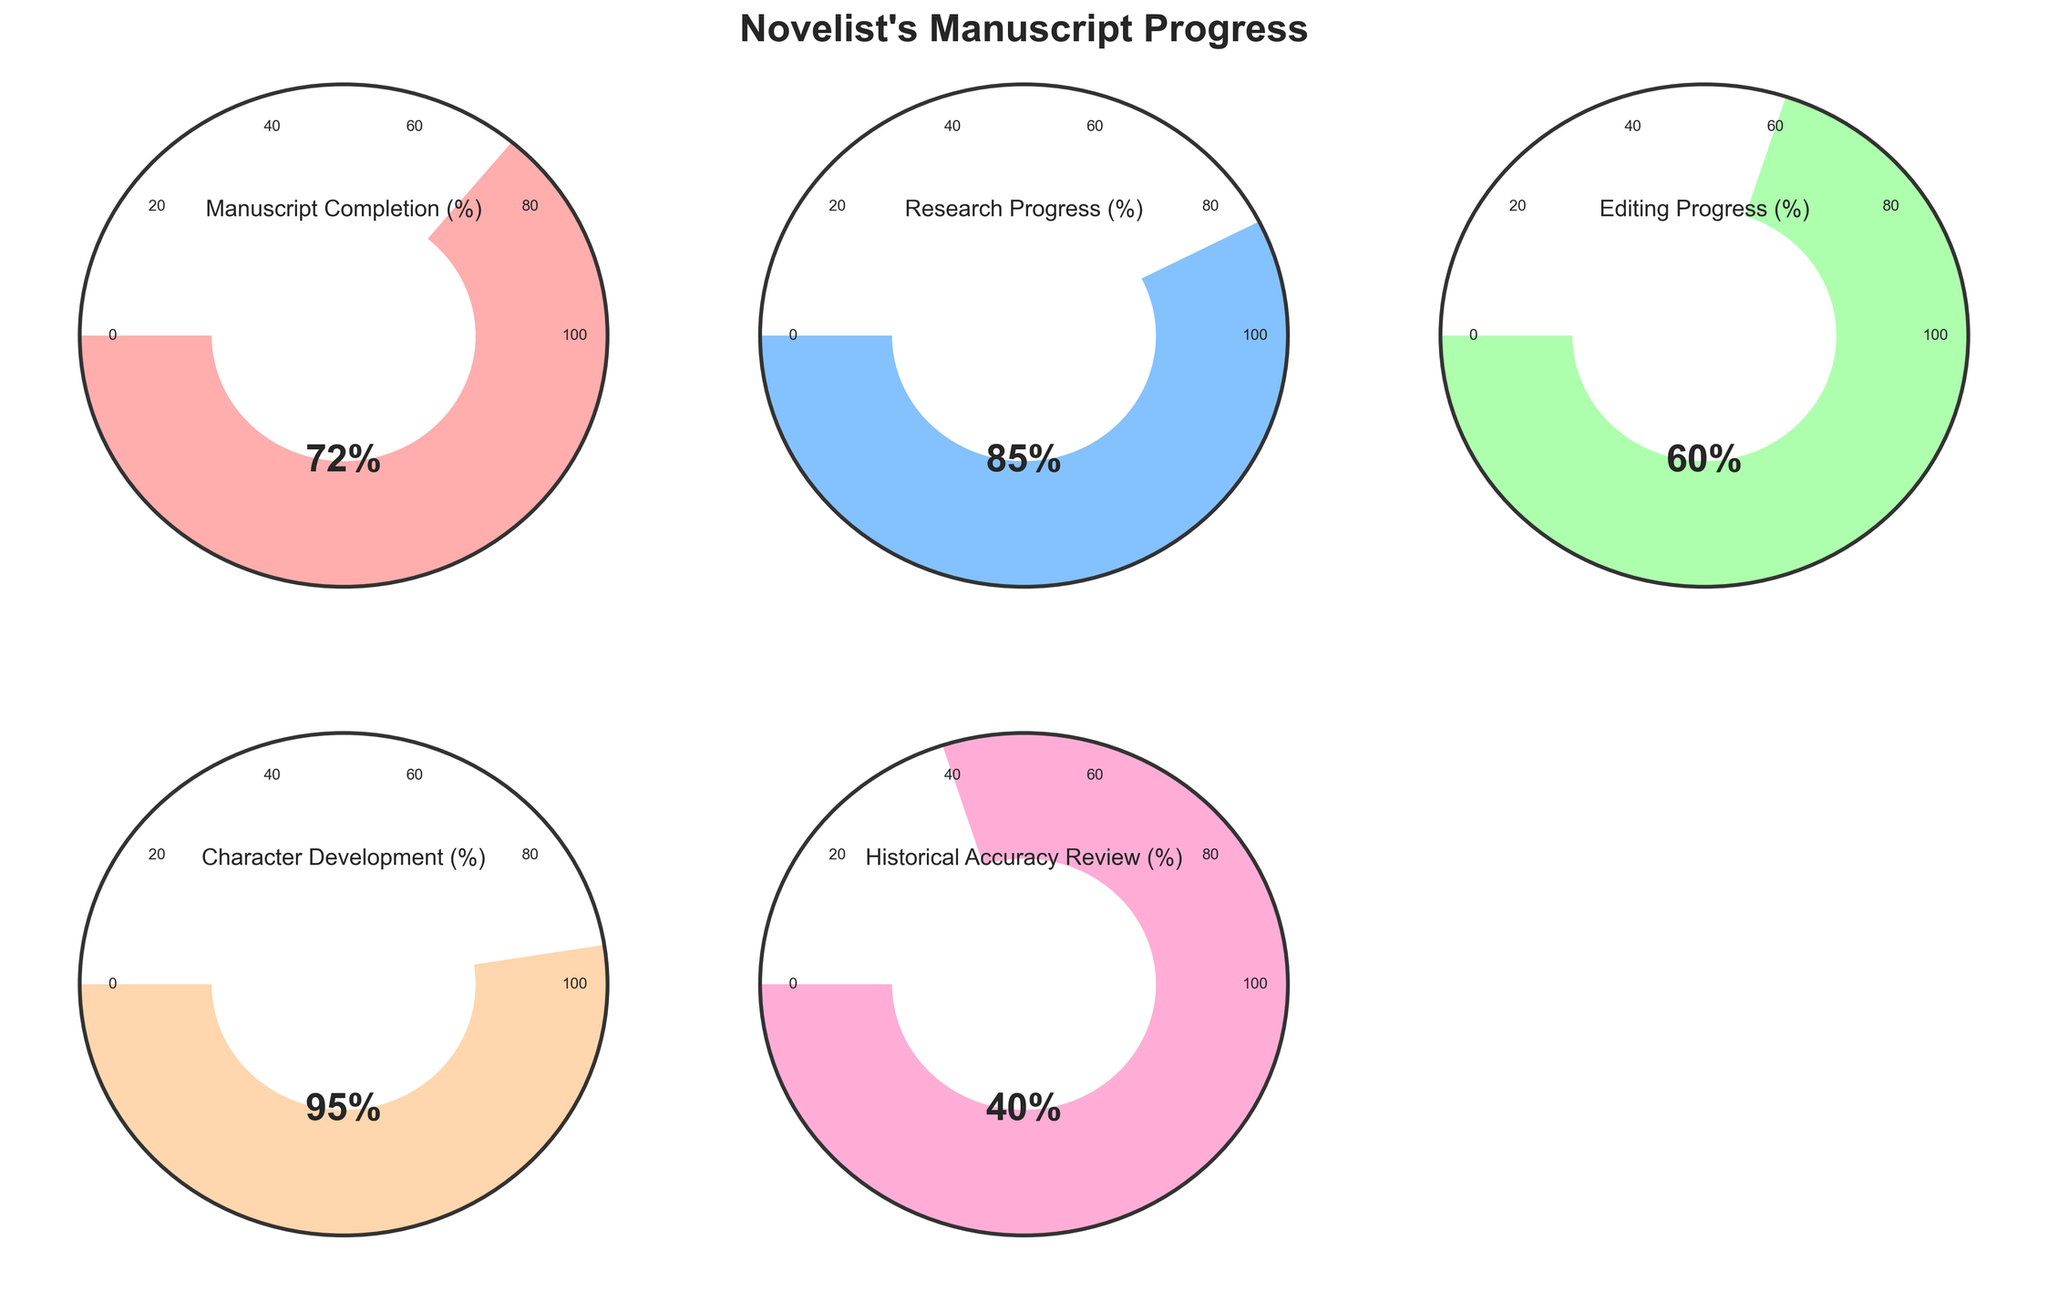What is the manuscript completion rate? The manuscript completion rate is directly provided in the gauge chart for "Manuscript Completion (%)" with a value of 72%.
Answer: 72% Which chart shows the highest progress value? By looking at all the gauge charts, the "Character Development (%)" has the highest progress value of 95%.
Answer: Character Development (%) What is the difference between the manuscript completion rate and the editing progress? The manuscript completion rate is 72% and the editing progress is 60%. The difference is 72 - 60 = 12%.
Answer: 12% Which progress value is the lowest? Among all the gauge charts, "Historical Accuracy Review (%)" has the lowest progress value of 40%.
Answer: Historical Accuracy Review (%) How many gauge charts are there in total in the figure? The figure contains 5 fully utilized gauge charts: Manuscript Completion, Research Progress, Editing Progress, Character Development, and Historical Accuracy Review. One subplot is unused.
Answer: 5 Compare the editing and research progress rates. Which one is higher and by how much? The editing progress is 60% and the research progress is 85%. Research progress is higher by 85 - 60 = 25%.
Answer: Research Progress higher by 25% What is the average progress rate of the data shown? Sum the progress values (72 + 85 + 60 + 95 + 40) = 352. Divide by the number of data points (5). The average is 352 / 5 = 70.4%.
Answer: 70.4% What title is given to the figure? The main title given to the figure is "Novelist's Manuscript Progress".
Answer: Novelist's Manuscript Progress Is the research progress rate more than double the historical accuracy review progress rate? The research progress is 85% and the historical accuracy review progress is 40%. By calculation, 40 * 2 = 80%, and 85% is more than 80%.
Answer: Yes What component has a progress rate 20% or more above the editing progress rate? The editing progress rate is 60%. The research progress (85%) and character development (95%) are both 20% or more above it: 
Research Progress: 85% - 60% = 25% 
Character Development: 95% - 60% = 35%.
Answer: Research Progress, Character Development 